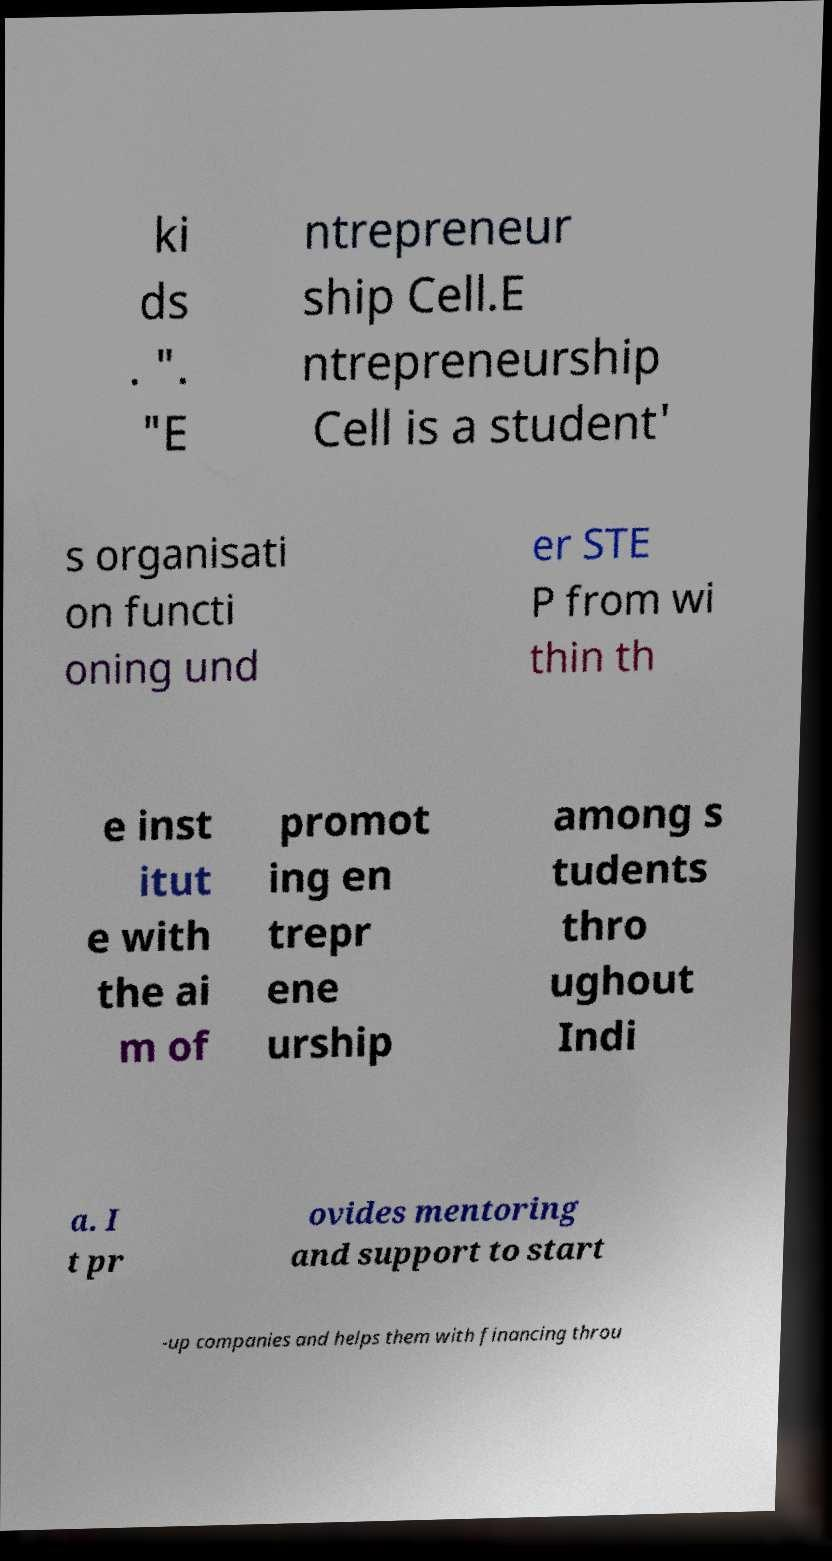Could you assist in decoding the text presented in this image and type it out clearly? ki ds . ". "E ntrepreneur ship Cell.E ntrepreneurship Cell is a student' s organisati on functi oning und er STE P from wi thin th e inst itut e with the ai m of promot ing en trepr ene urship among s tudents thro ughout Indi a. I t pr ovides mentoring and support to start -up companies and helps them with financing throu 